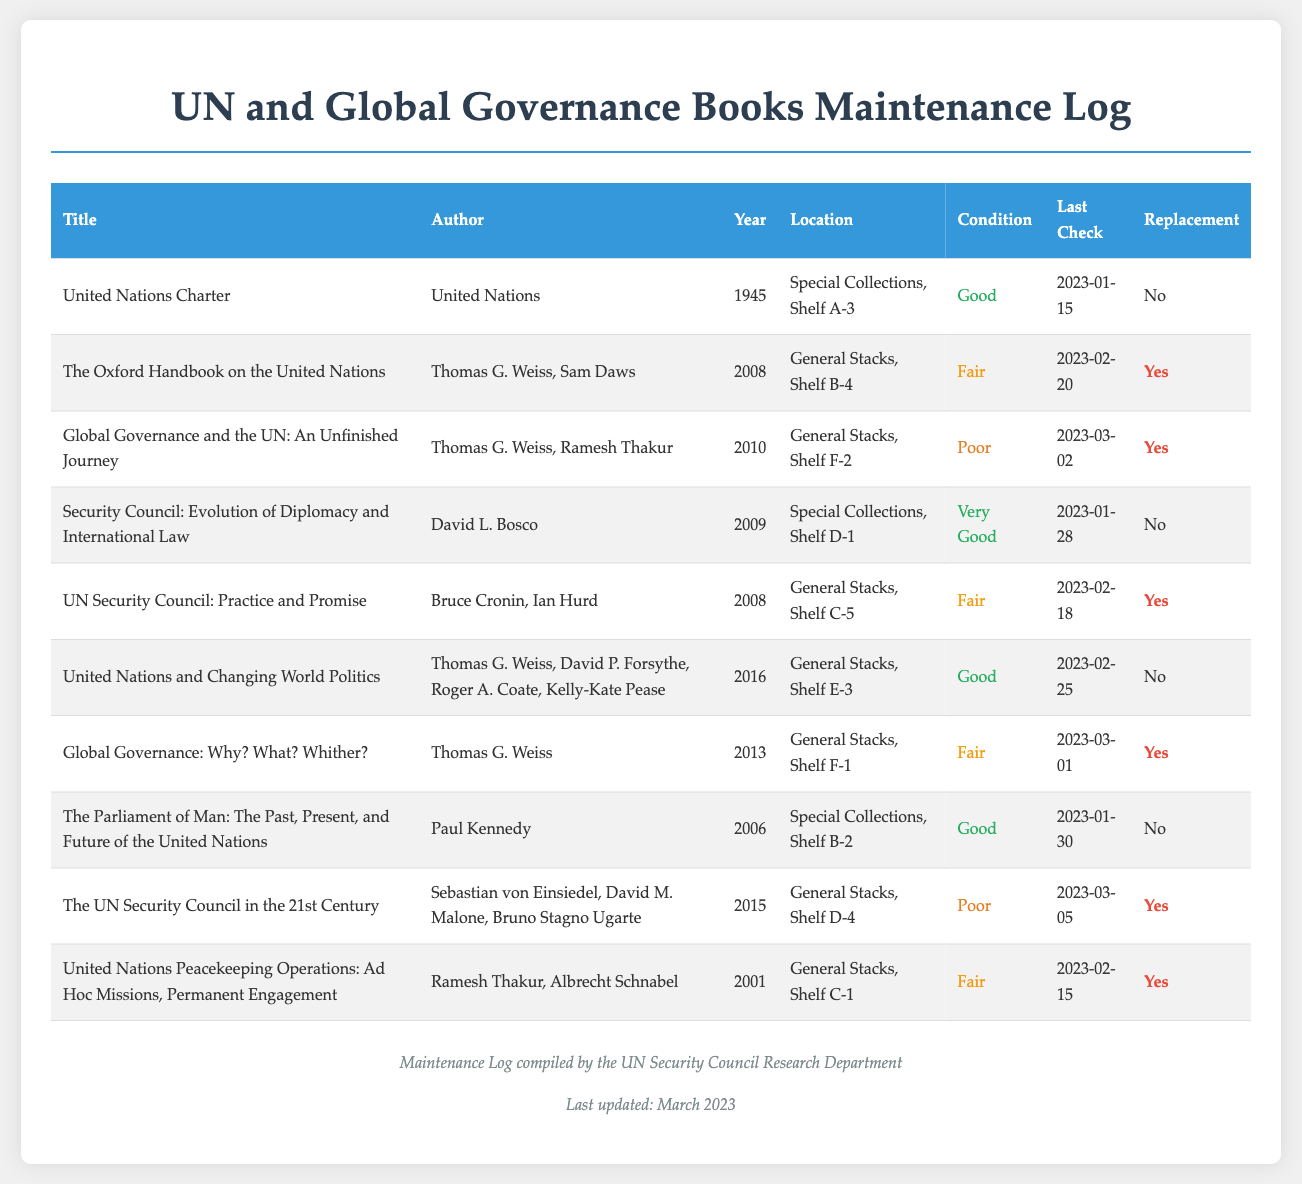What is the title of the book authored by the United Nations? The title in the log for this author is listed as the "United Nations Charter."
Answer: United Nations Charter Which shelf location holds "Global Governance and the UN: An Unfinished Journey"? The shelf location for this book is indicated in the log as "General Stacks, Shelf F-2."
Answer: General Stacks, Shelf F-2 What condition is "The Oxford Handbook on the United Nations" in? The log states that this book is in "Fair" condition.
Answer: Fair How many books in the log require replacement? By counting the "Yes" entries under the Replacement column, the number is three.
Answer: 3 Who are the authors of "United Nations Peacekeeping Operations: Ad Hoc Missions, Permanent Engagement"? The authors mentioned in the log are Ramesh Thakur and Albrecht Schnabel.
Answer: Ramesh Thakur, Albrecht Schnabel When was the last check conducted for "The UN Security Council in the 21st Century"? The log indicates that the last check date is "2023-03-05."
Answer: 2023-03-05 Which book is located on Shelf A-3? According to the log, the book on Shelf A-3 is the "United Nations Charter."
Answer: United Nations Charter What is the publication year of "UN Security Council: Practice and Promise"? This book was published in the year "2008" as specified in the log.
Answer: 2008 What is the condition of the book "Global Governance: Why? What? Whither?"? The log specifies the condition as "Fair."
Answer: Fair 